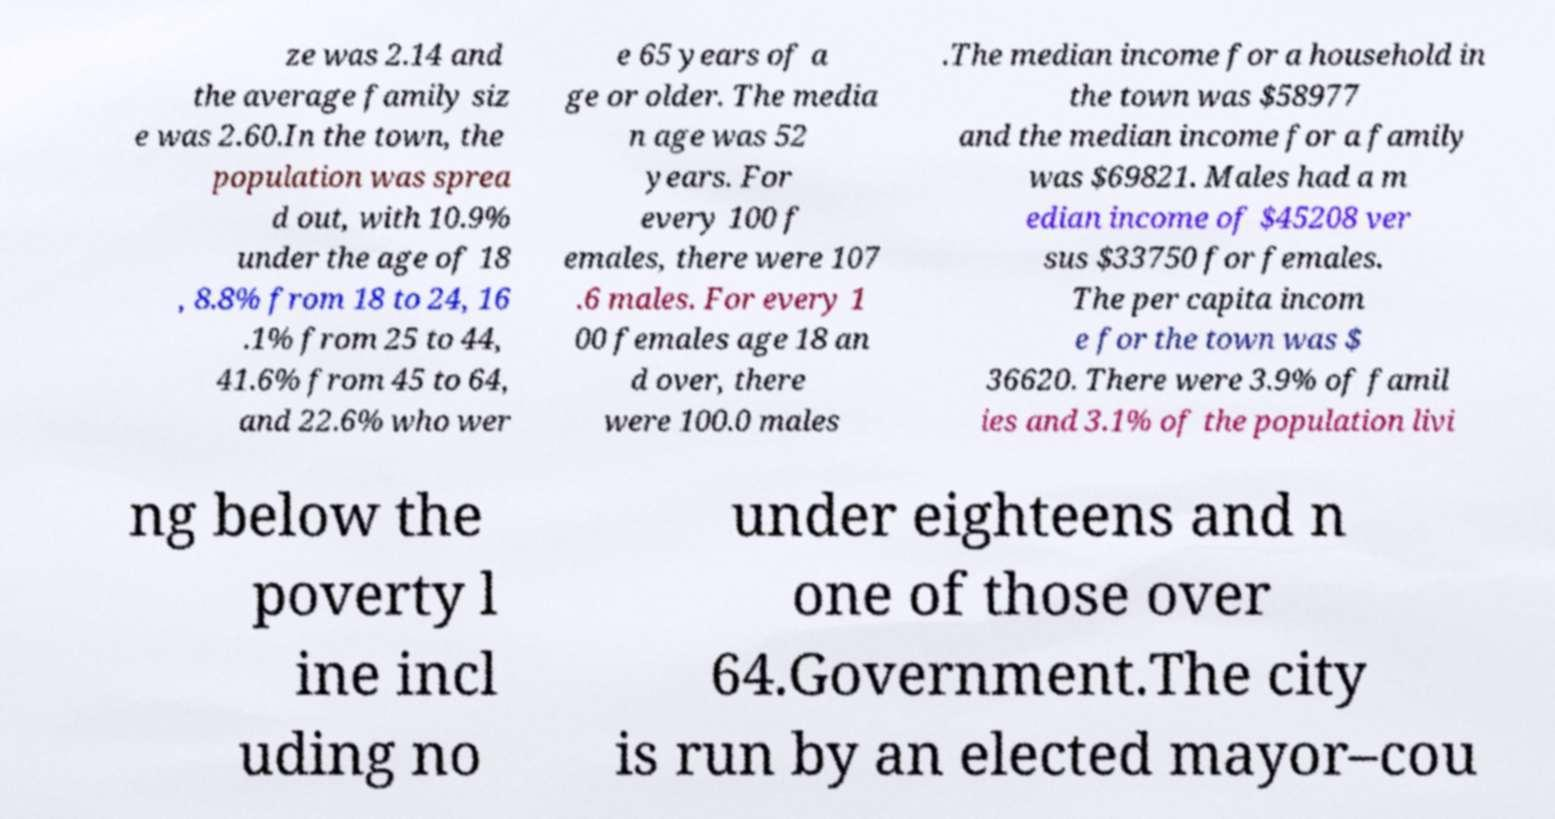Could you assist in decoding the text presented in this image and type it out clearly? ze was 2.14 and the average family siz e was 2.60.In the town, the population was sprea d out, with 10.9% under the age of 18 , 8.8% from 18 to 24, 16 .1% from 25 to 44, 41.6% from 45 to 64, and 22.6% who wer e 65 years of a ge or older. The media n age was 52 years. For every 100 f emales, there were 107 .6 males. For every 1 00 females age 18 an d over, there were 100.0 males .The median income for a household in the town was $58977 and the median income for a family was $69821. Males had a m edian income of $45208 ver sus $33750 for females. The per capita incom e for the town was $ 36620. There were 3.9% of famil ies and 3.1% of the population livi ng below the poverty l ine incl uding no under eighteens and n one of those over 64.Government.The city is run by an elected mayor–cou 